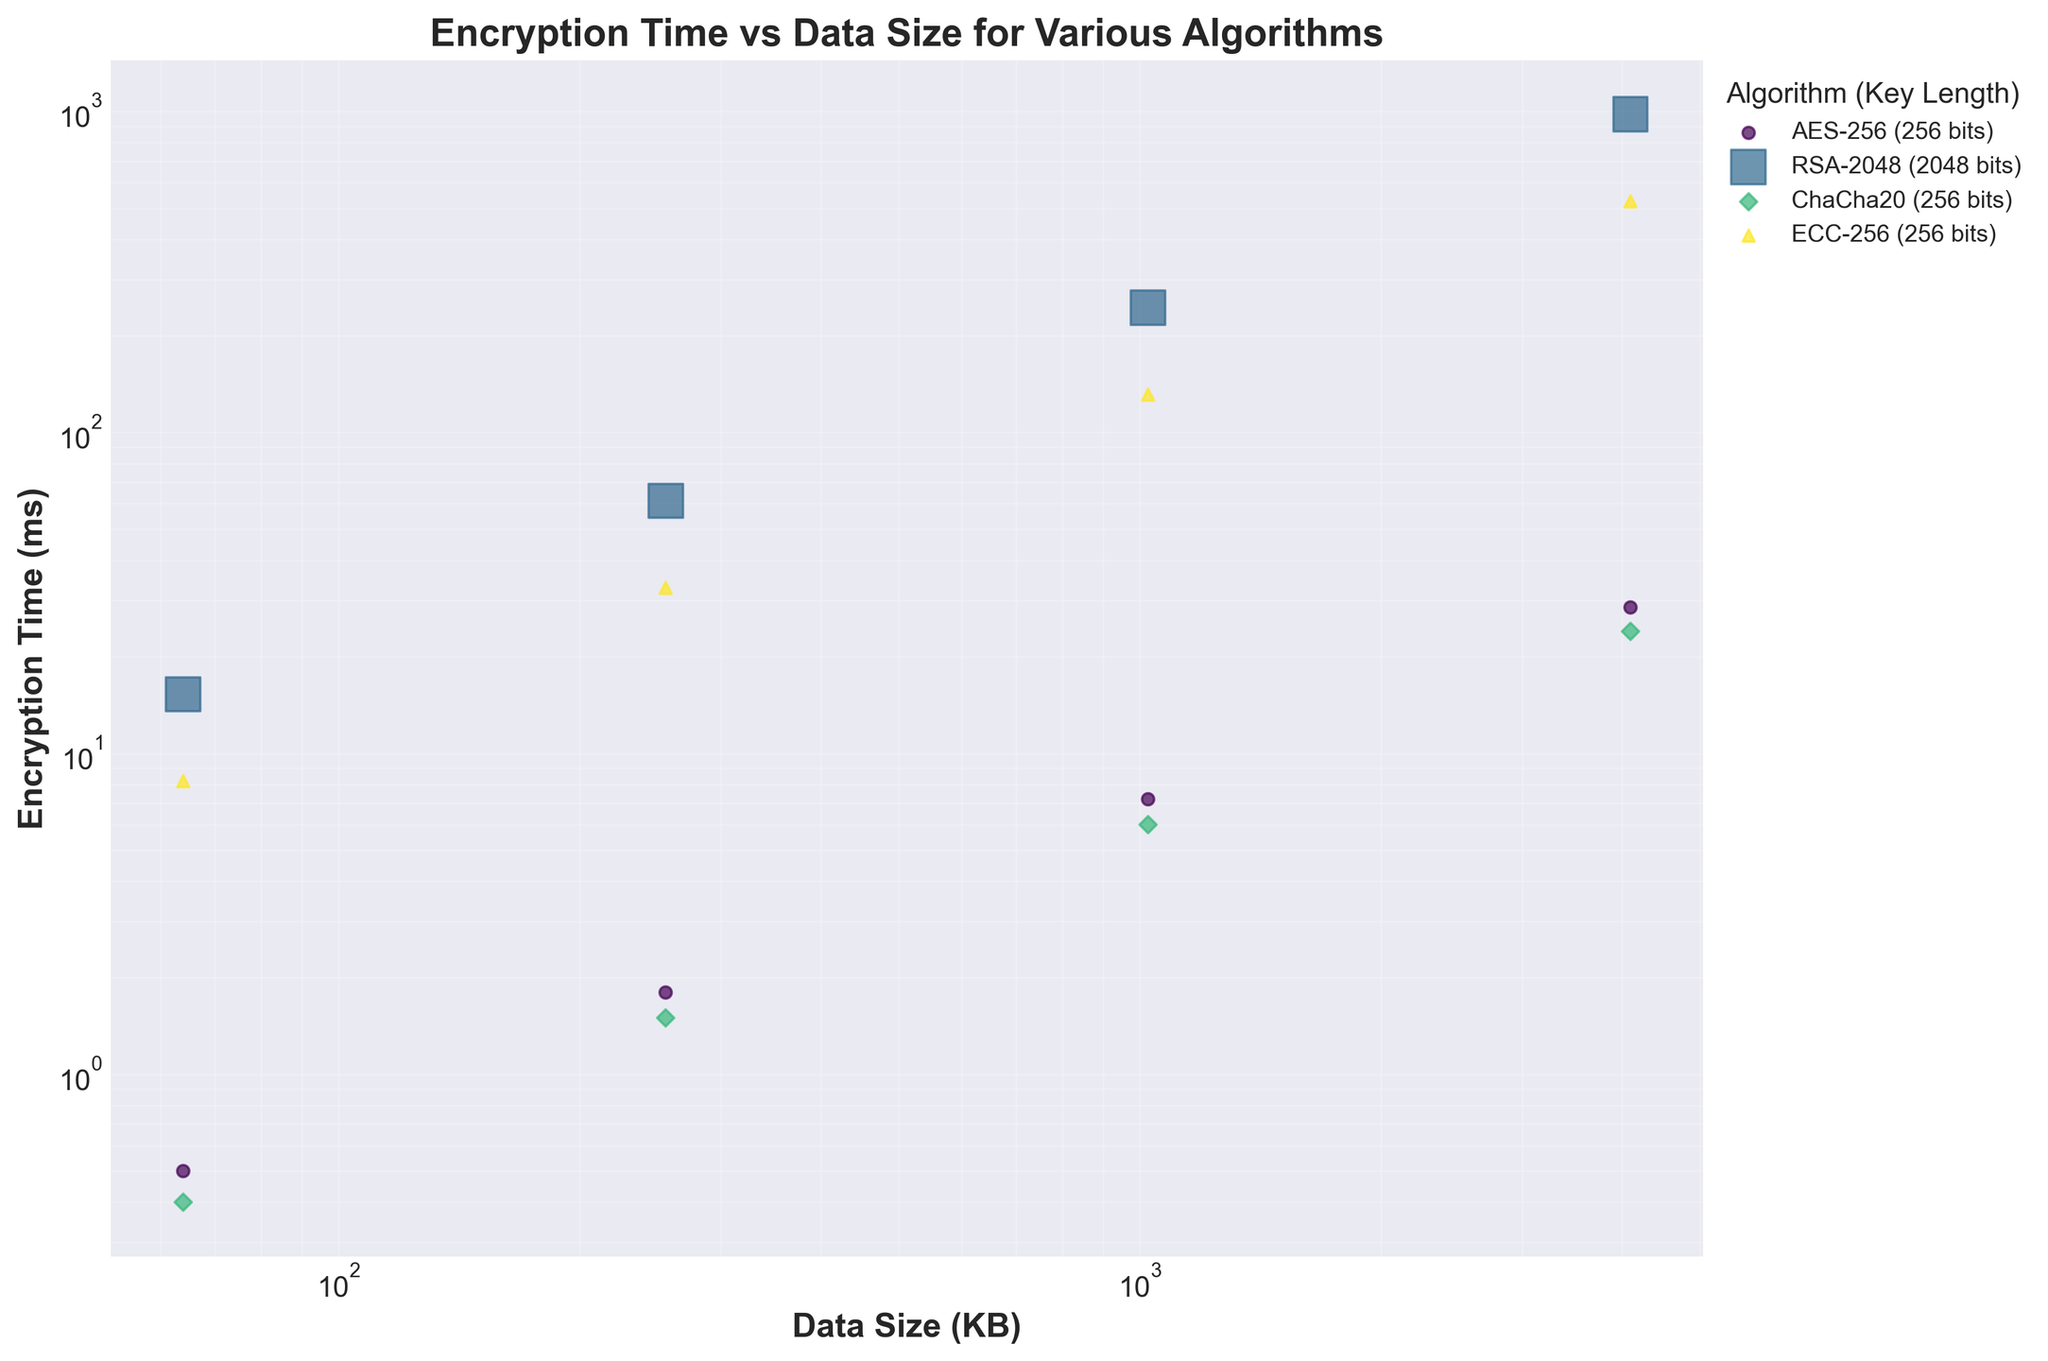What is the title of the figure? The title is usually displayed at the top of the figure and is clearly labeled to provide the name or subject of the visualization.
Answer: Encryption Time vs Data Size for Various Algorithms Which axis represents the data size? The labels on the axes provide information about what each axis represents. The x-axis is labeled "Data Size (KB)."
Answer: x-axis How many different algorithms are represented in the plot? Each algorithm is uniquely distinguished, often by different colors or shapes. We can count these unique markers or color representations.
Answer: 4 Which algorithm appears to have the fastest encryption time for a data size of 64 KB? Look at the data points corresponding to 64 KB on the x-axis. Identify which algorithm has the lowest y-coordinate (encryption time) among them.
Answer: ChaCha20 For a data size of 4096 KB, which algorithm has the longest encryption time? Locate the data points at 4096 KB on the x-axis and observe which one has the highest y-coordinate (encryption time).
Answer: RSA-2048 How does the encryption time for AES-256 change as the data size increases from 64 KB to 4096 KB? We need to observe the data points for AES-256 and see the trend as the data size increases along the x-axis. The y-coordinate indicates the encryption time, and we should notice an increasing trend.
Answer: Increases Compare the encryption times for ChaCha20 and ECC-256 at a data size of 1024 KB. Which is faster? Find the data points for both ChaCha20 and ECC-256 at 1024 KB and compare their y-coordinates (encryption times). The lower y-coordinate indicates the faster encryption time.
Answer: ChaCha20 What is the key length used for RSA-2048 in this plot? The legend or data points indicate the key length for each algorithm. For RSA-2048, the key length is explicitly mentioned in the legend.
Answer: 2048 bits Which algorithm shows the least variation in encryption time across different data sizes? Observe the range of y-coordinates (encryption times) for each algorithm. The one with the smallest range indicates the least variation.
Answer: ChaCha20 Do symmetric algorithms (AES-256, ChaCha20) generally perform better than asymmetric algorithms (RSA-2048, ECC-256) in terms of encryption time? Analyze the overall trends and data points for symmetric (AES-256, ChaCha20) and asymmetric algorithms (RSA-2048, ECC-256). Compare their encryption times across all data sizes. Symmetric algorithms generally have lower y-coordinates (encryption times).
Answer: Yes 